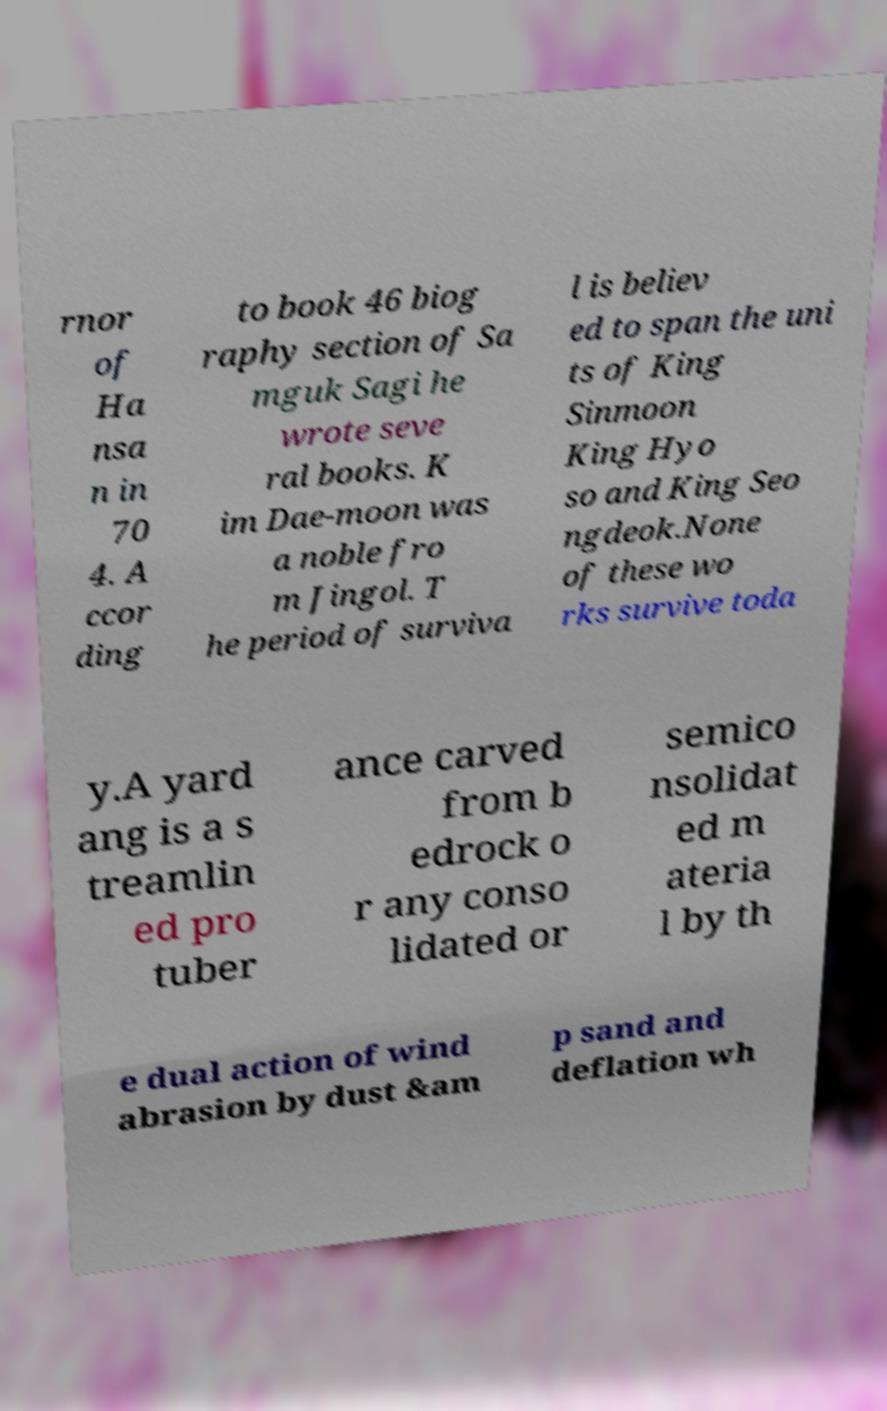What messages or text are displayed in this image? I need them in a readable, typed format. rnor of Ha nsa n in 70 4. A ccor ding to book 46 biog raphy section of Sa mguk Sagi he wrote seve ral books. K im Dae-moon was a noble fro m Jingol. T he period of surviva l is believ ed to span the uni ts of King Sinmoon King Hyo so and King Seo ngdeok.None of these wo rks survive toda y.A yard ang is a s treamlin ed pro tuber ance carved from b edrock o r any conso lidated or semico nsolidat ed m ateria l by th e dual action of wind abrasion by dust &am p sand and deflation wh 